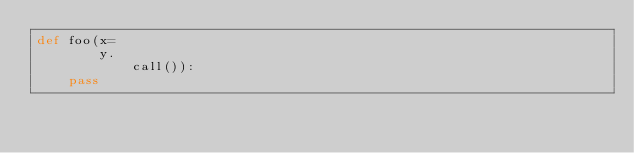Convert code to text. <code><loc_0><loc_0><loc_500><loc_500><_Python_>def foo(x=
        y.
            call()):
    pass</code> 